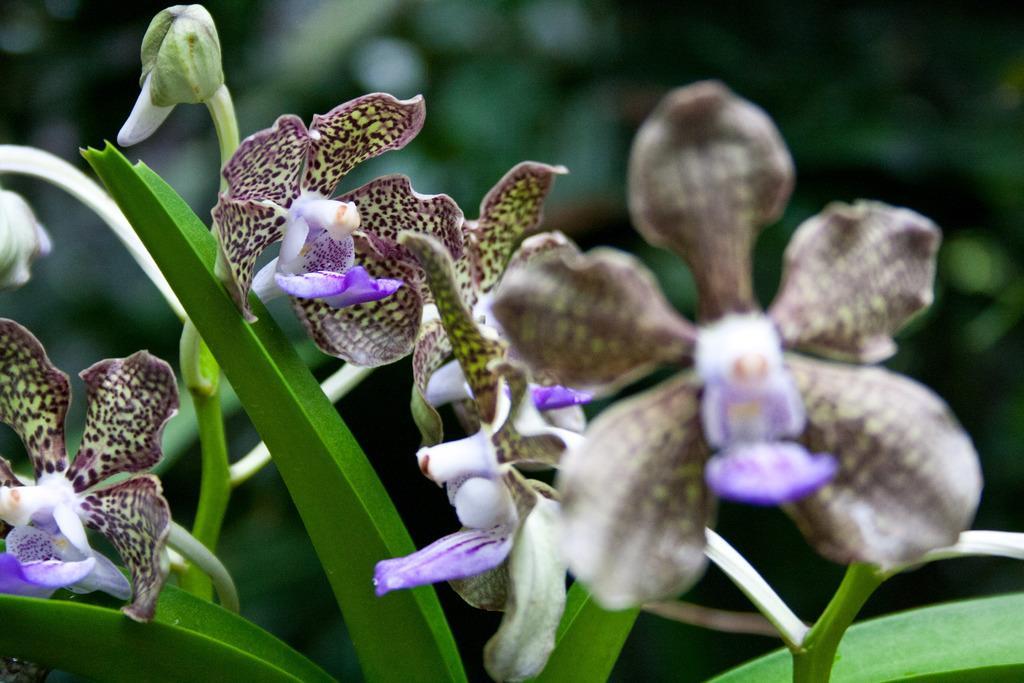In one or two sentences, can you explain what this image depicts? In this image there are flowers and leaves, in the background it is blurred. 